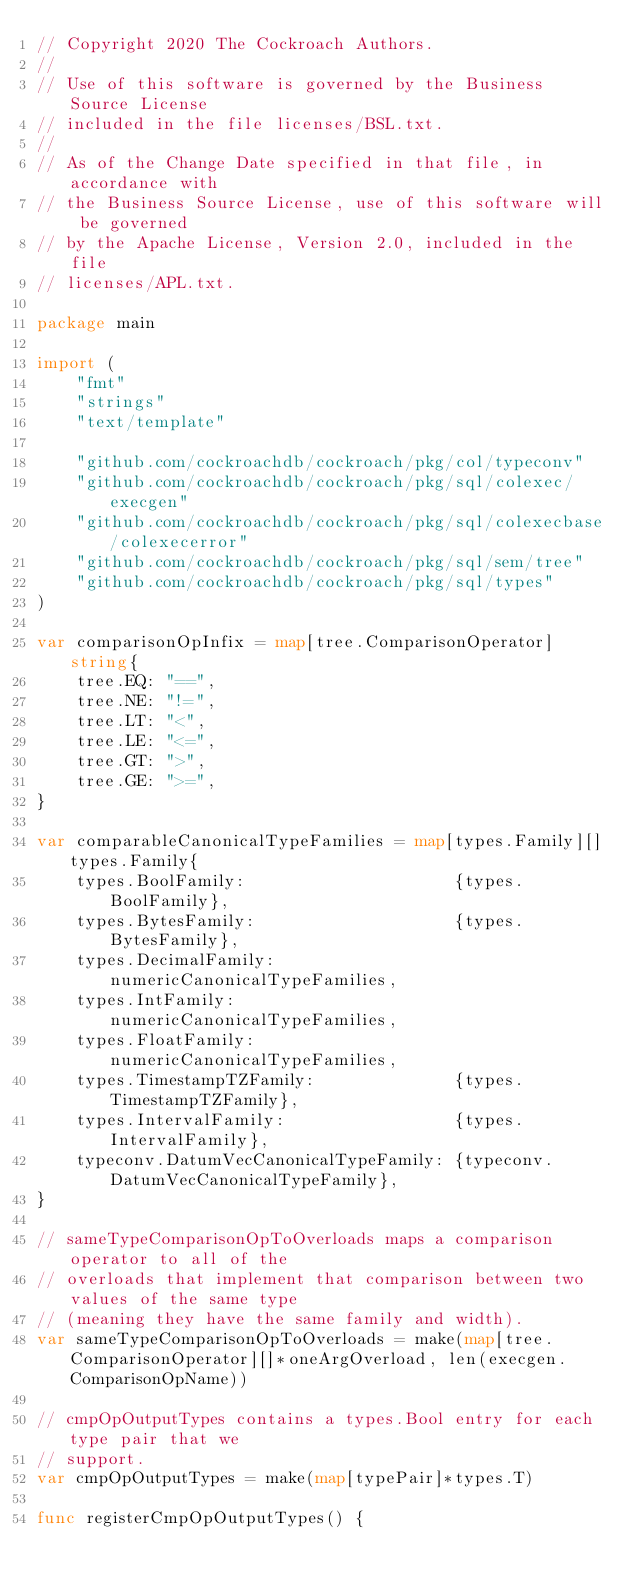Convert code to text. <code><loc_0><loc_0><loc_500><loc_500><_Go_>// Copyright 2020 The Cockroach Authors.
//
// Use of this software is governed by the Business Source License
// included in the file licenses/BSL.txt.
//
// As of the Change Date specified in that file, in accordance with
// the Business Source License, use of this software will be governed
// by the Apache License, Version 2.0, included in the file
// licenses/APL.txt.

package main

import (
	"fmt"
	"strings"
	"text/template"

	"github.com/cockroachdb/cockroach/pkg/col/typeconv"
	"github.com/cockroachdb/cockroach/pkg/sql/colexec/execgen"
	"github.com/cockroachdb/cockroach/pkg/sql/colexecbase/colexecerror"
	"github.com/cockroachdb/cockroach/pkg/sql/sem/tree"
	"github.com/cockroachdb/cockroach/pkg/sql/types"
)

var comparisonOpInfix = map[tree.ComparisonOperator]string{
	tree.EQ: "==",
	tree.NE: "!=",
	tree.LT: "<",
	tree.LE: "<=",
	tree.GT: ">",
	tree.GE: ">=",
}

var comparableCanonicalTypeFamilies = map[types.Family][]types.Family{
	types.BoolFamily:                     {types.BoolFamily},
	types.BytesFamily:                    {types.BytesFamily},
	types.DecimalFamily:                  numericCanonicalTypeFamilies,
	types.IntFamily:                      numericCanonicalTypeFamilies,
	types.FloatFamily:                    numericCanonicalTypeFamilies,
	types.TimestampTZFamily:              {types.TimestampTZFamily},
	types.IntervalFamily:                 {types.IntervalFamily},
	typeconv.DatumVecCanonicalTypeFamily: {typeconv.DatumVecCanonicalTypeFamily},
}

// sameTypeComparisonOpToOverloads maps a comparison operator to all of the
// overloads that implement that comparison between two values of the same type
// (meaning they have the same family and width).
var sameTypeComparisonOpToOverloads = make(map[tree.ComparisonOperator][]*oneArgOverload, len(execgen.ComparisonOpName))

// cmpOpOutputTypes contains a types.Bool entry for each type pair that we
// support.
var cmpOpOutputTypes = make(map[typePair]*types.T)

func registerCmpOpOutputTypes() {</code> 